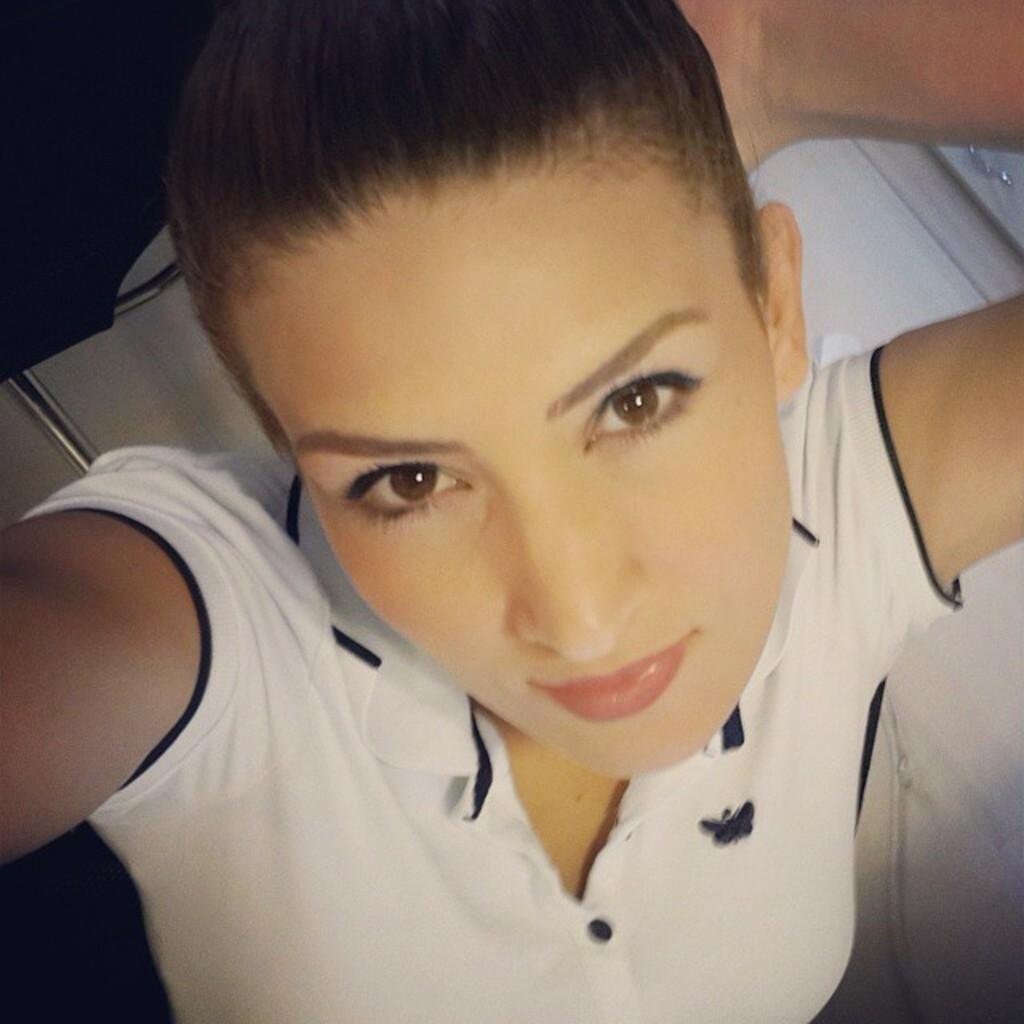Who is the main subject in the image? There is a girl in the image. What is the girl wearing? The girl is wearing a white t-shirt. What activity is the girl engaged in? The girl is taking a selfie. What else can be seen in the image besides the girl? There are objects beside the girl. How many trees can be seen in the image? There are no trees visible in the image. What type of boats are present in the image? There are no boats present in the image. 